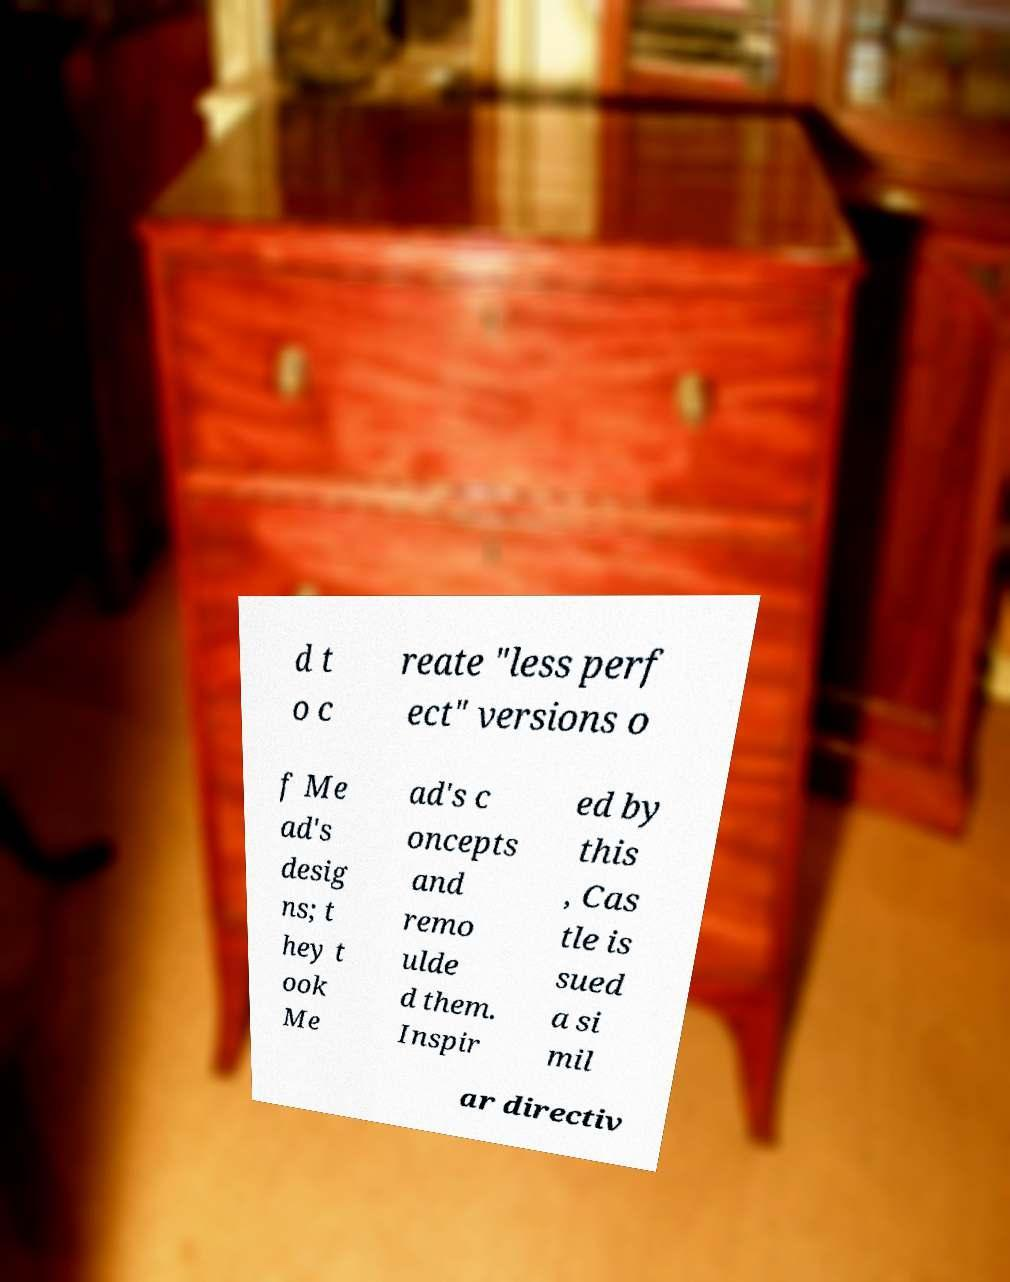Please read and relay the text visible in this image. What does it say? d t o c reate "less perf ect" versions o f Me ad's desig ns; t hey t ook Me ad's c oncepts and remo ulde d them. Inspir ed by this , Cas tle is sued a si mil ar directiv 